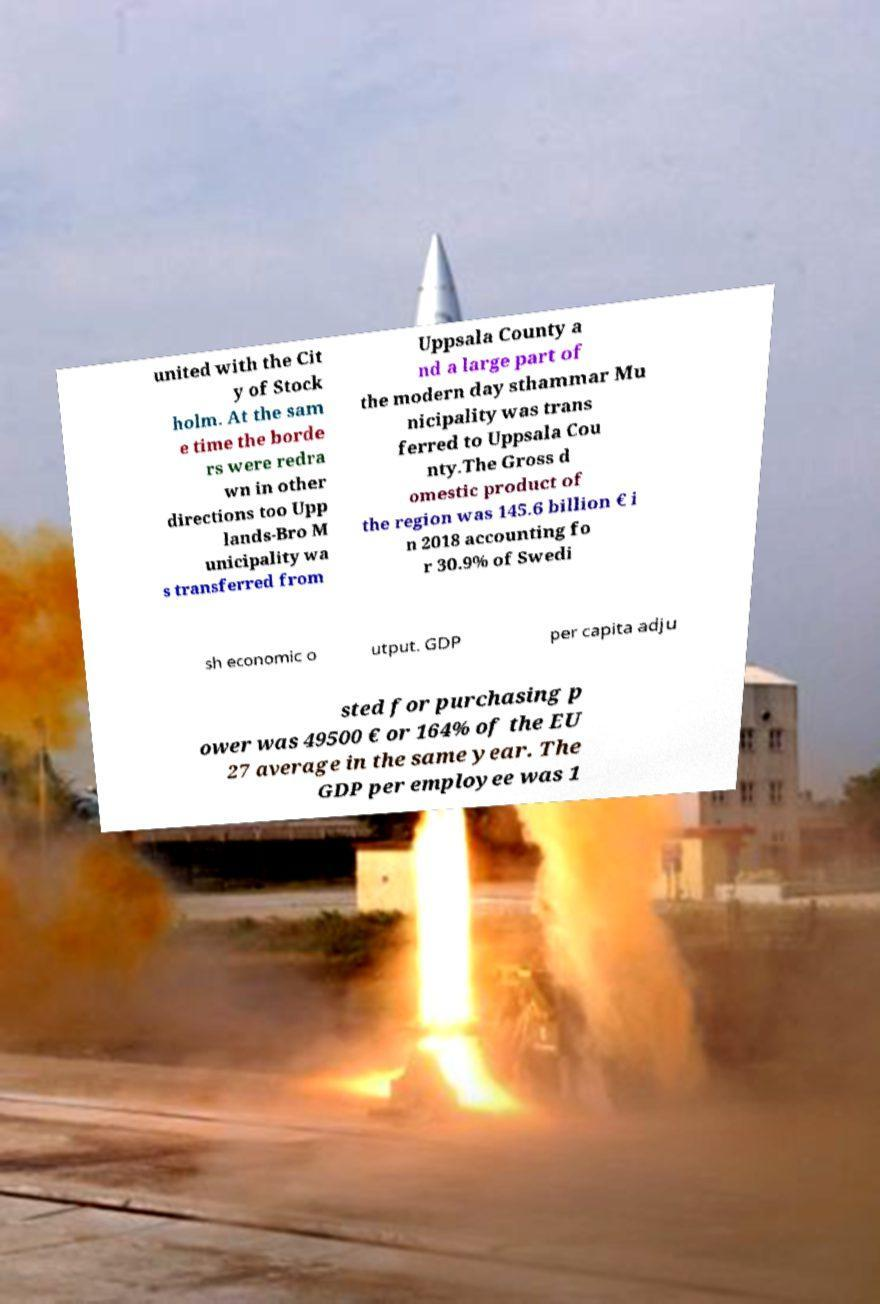What messages or text are displayed in this image? I need them in a readable, typed format. united with the Cit y of Stock holm. At the sam e time the borde rs were redra wn in other directions too Upp lands-Bro M unicipality wa s transferred from Uppsala County a nd a large part of the modern day sthammar Mu nicipality was trans ferred to Uppsala Cou nty.The Gross d omestic product of the region was 145.6 billion € i n 2018 accounting fo r 30.9% of Swedi sh economic o utput. GDP per capita adju sted for purchasing p ower was 49500 € or 164% of the EU 27 average in the same year. The GDP per employee was 1 